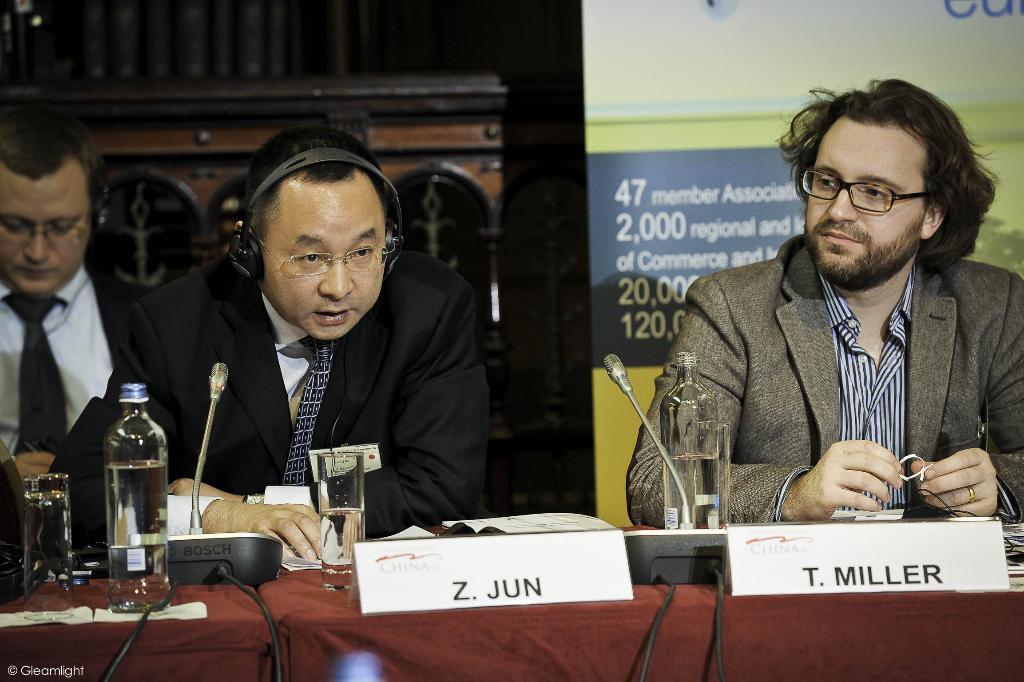Describe this image in one or two sentences. There are 3 persons in the image, 2 men sitting besides a table, another man sitting in a left corner. A man towards the right, he is wearing a spectacles, striped shirt, grey blazers, holding a wire. Middle man, he is wearing a black blazer and a tie. On the table there is a glass, bottle, boards and mike's. In the background there is a board and some text printed on it. 